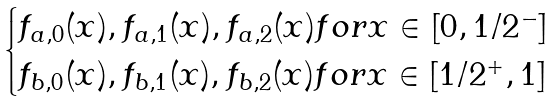<formula> <loc_0><loc_0><loc_500><loc_500>\begin{cases} f _ { a , 0 } ( x ) , f _ { a , 1 } ( x ) , f _ { a , 2 } ( x ) f o r x \in [ 0 , 1 / 2 ^ { - } ] \\ f _ { b , 0 } ( x ) , f _ { b , 1 } ( x ) , f _ { b , 2 } ( x ) f o r x \in [ 1 / 2 ^ { + } , 1 ] \end{cases}</formula> 